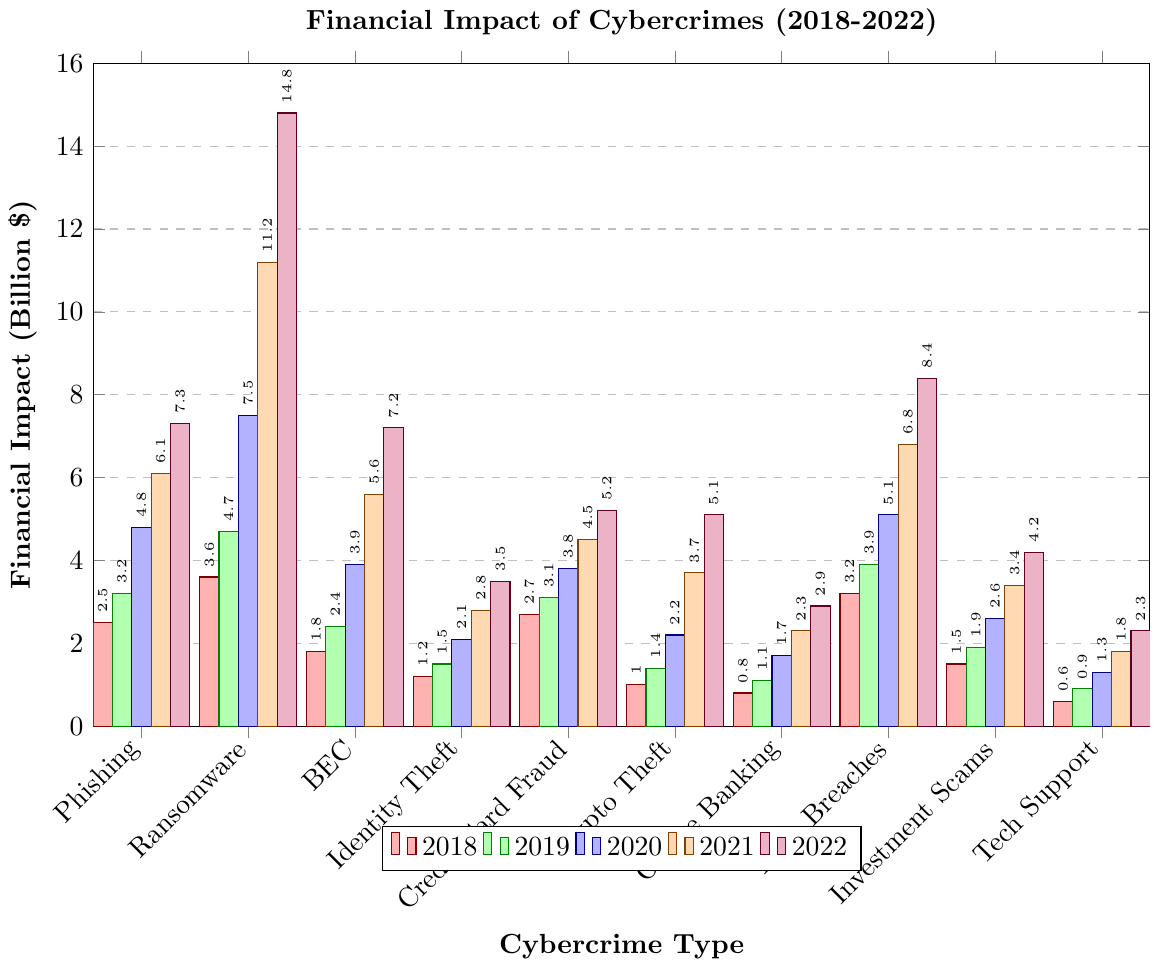What type of cybercrime had the highest financial impact in 2021? To find the cybercrime type with the highest financial impact in 2021, look at the tallest orange bar. The tallest orange bar represents Ransomware with a financial impact of 11.2 billion dollars.
Answer: Ransomware How did the financial impact of Phishing evolve from 2018 to 2022? To understand the evolution of the financial impact of Phishing, observe the heights of the bars across the years for Phishing. The values increase as follows: 2.5, 3.2, 4.8, 6.1, 7.3 billion dollars from 2018 to 2022.
Answer: It increased progressively every year from 2.5 billion to 7.3 billion dollars Which cybercrime had the lowest financial impact in 2018 and what was the value? To find the cybercrime with the lowest financial impact for 2018, identify the shortest red bar. The shortest red bar corresponds to Tech Support Scams with a financial impact of 0.6 billion dollars.
Answer: Tech Support Scams, 0.6 billion dollars What's the average financial impact of Cryptocurrency Theft across all years? To calculate the average financial impact of Cryptocurrency Theft, sum the financial impacts from 2018 to 2022 and divide by the number of years. This is calculated as (1.0 + 1.4 + 2.2 + 3.7 + 5.1) / 5 = 13.4 / 5 = 2.68.
Answer: 2.68 billion dollars Did any cybercrime types have the same financial impact in any given year? To determine if any cybercrimes had the same financial impact in any given year, compare the heights of the bars for each year. No bars appear to have the exact same height in any given year upon visual inspection.
Answer: No Which cybercrime showed the greatest increase in financial impact between 2018 and 2019? To identify the cybercrime with the greatest increase between 2018 and 2019, calculate the difference for each type: Phishing (0.7), Ransomware (1.1), BEC (0.6), Identity Theft (0.3), Credit Card Fraud (0.4), Crypto Theft (0.4), Online Banking (0.3), Data Breaches (0.7), Investment Scams (0.4), Tech Support (0.3). Ransomware had the largest increase of 1.1 billion dollars.
Answer: Ransomware What is the sum of the financial impacts of Data Breaches in 2020 and 2022? To find this sum, add the financial impacts of Data Breaches for these years. This is calculated as 5.1 billion dollars in 2020 + 8.4 billion dollars in 2022 = 13.5 billion dollars.
Answer: 13.5 billion dollars Which cybercrime type has shown consistent year-over-year growth without any decline? Review the bars for each cybercrime type across the years to see which ones consistently increase. Phishing, Ransomware, BEC, Identity Theft, Credit Card Fraud, Crypto Theft, Online Banking, Data Breaches, Investment Scams, and Tech Support all show consistent growth without decline.
Answer: All types When comparing Tech Support Scams and Identity Theft, in which year was the financial impact of Tech Support Scams closest to that of Identity Theft? To determine this, review the bars for both Types across the years and find the year with the smallest difference. In 2022, Tech Support Scams (2.3 billion dollars) and Identity Theft (3.5 billion dollars) had a difference of 1.2 billion dollars, which is relatively closest across all years.
Answer: 2022 